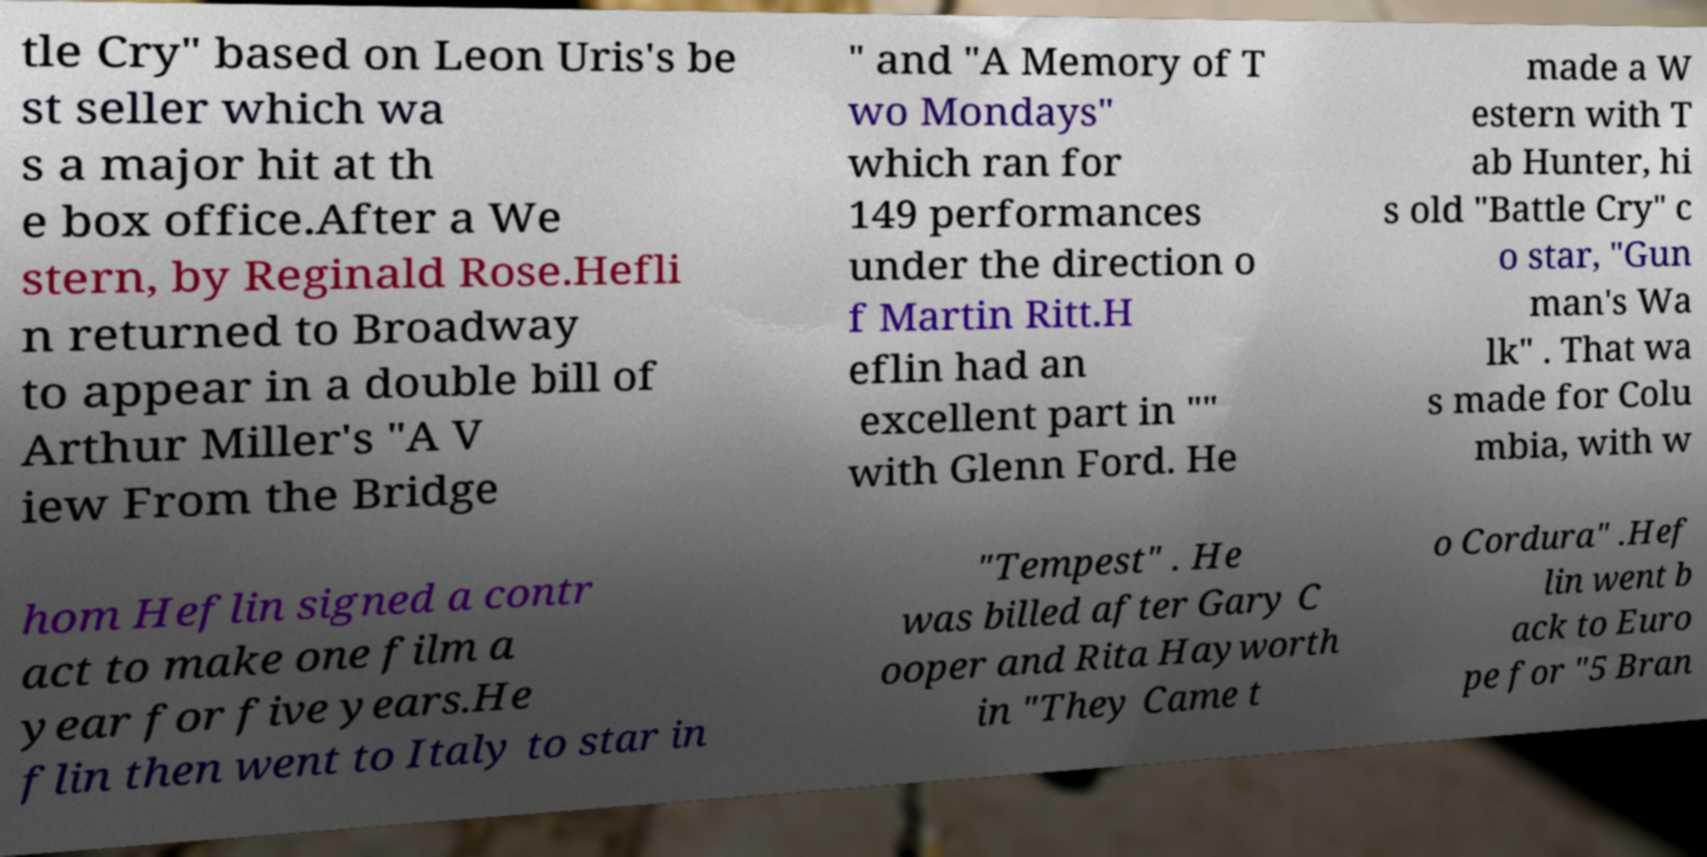Please identify and transcribe the text found in this image. tle Cry" based on Leon Uris's be st seller which wa s a major hit at th e box office.After a We stern, by Reginald Rose.Hefli n returned to Broadway to appear in a double bill of Arthur Miller's "A V iew From the Bridge " and "A Memory of T wo Mondays" which ran for 149 performances under the direction o f Martin Ritt.H eflin had an excellent part in "" with Glenn Ford. He made a W estern with T ab Hunter, hi s old "Battle Cry" c o star, "Gun man's Wa lk" . That wa s made for Colu mbia, with w hom Heflin signed a contr act to make one film a year for five years.He flin then went to Italy to star in "Tempest" . He was billed after Gary C ooper and Rita Hayworth in "They Came t o Cordura" .Hef lin went b ack to Euro pe for "5 Bran 